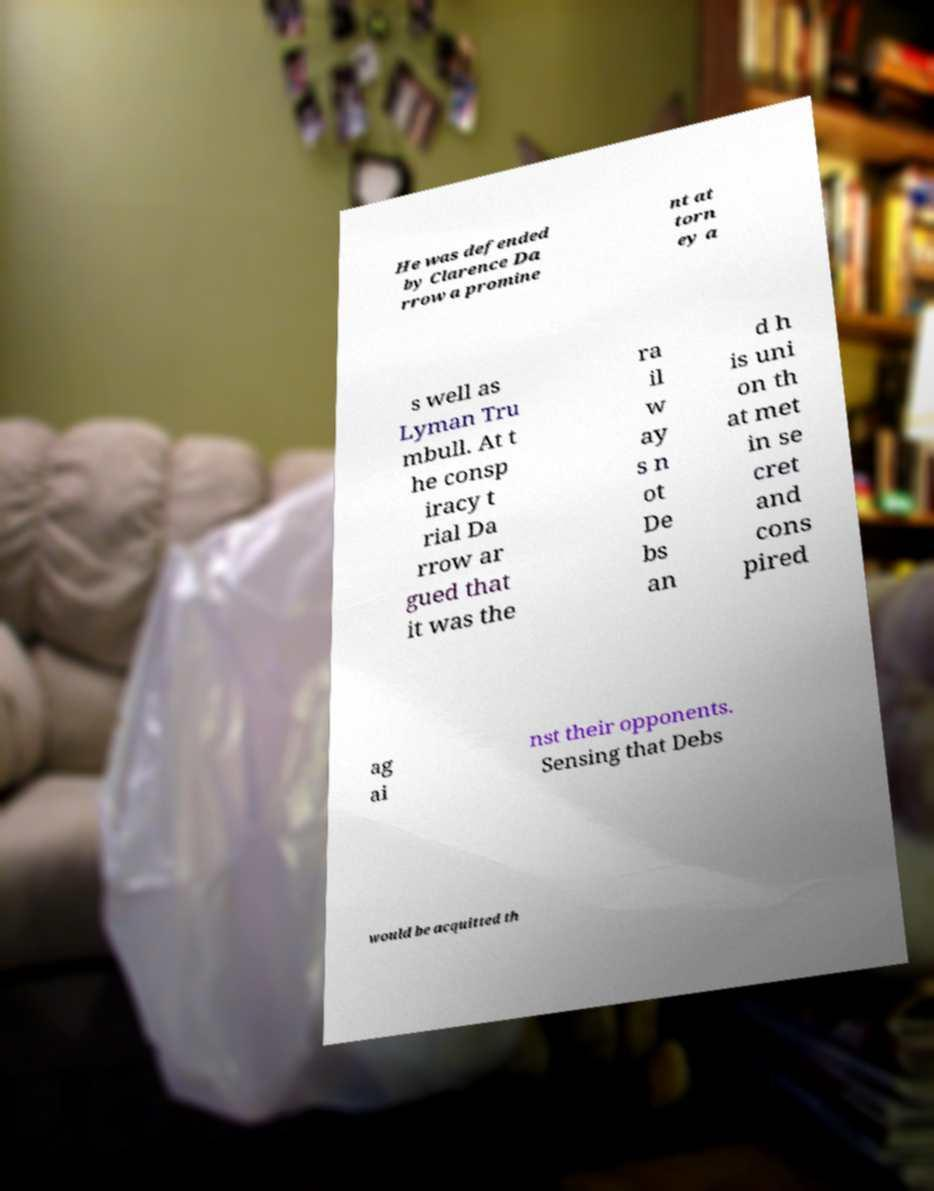Can you accurately transcribe the text from the provided image for me? He was defended by Clarence Da rrow a promine nt at torn ey a s well as Lyman Tru mbull. At t he consp iracy t rial Da rrow ar gued that it was the ra il w ay s n ot De bs an d h is uni on th at met in se cret and cons pired ag ai nst their opponents. Sensing that Debs would be acquitted th 